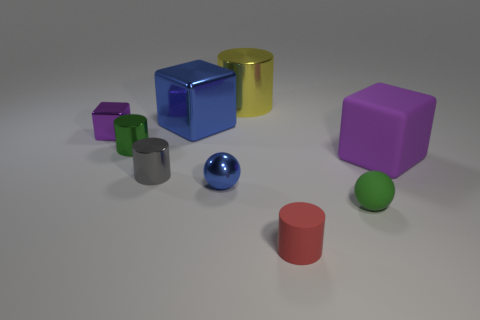Add 5 red objects. How many red objects are left? 6 Add 5 tiny yellow metallic things. How many tiny yellow metallic things exist? 5 Subtract all purple blocks. How many blocks are left? 1 Subtract all tiny purple cubes. How many cubes are left? 2 Subtract 0 yellow balls. How many objects are left? 9 Subtract all blocks. How many objects are left? 6 Subtract 1 blocks. How many blocks are left? 2 Subtract all yellow cylinders. Subtract all yellow cubes. How many cylinders are left? 3 Subtract all gray spheres. How many brown cubes are left? 0 Subtract all red things. Subtract all tiny metal balls. How many objects are left? 7 